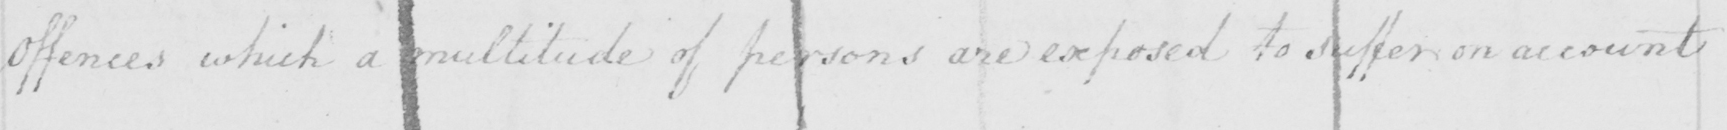Transcribe the text shown in this historical manuscript line. offences which a multitude of persons are exposed to suffer on account 